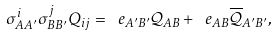Convert formula to latex. <formula><loc_0><loc_0><loc_500><loc_500>\sigma _ { A A ^ { \prime } } ^ { i } \sigma _ { B B ^ { \prime } } ^ { j } Q _ { i j } = \ e _ { A ^ { \prime } B ^ { \prime } } \mathcal { Q } _ { A B } + \ e _ { A B } \overline { \mathcal { Q } } _ { A ^ { \prime } B ^ { \prime } } ,</formula> 